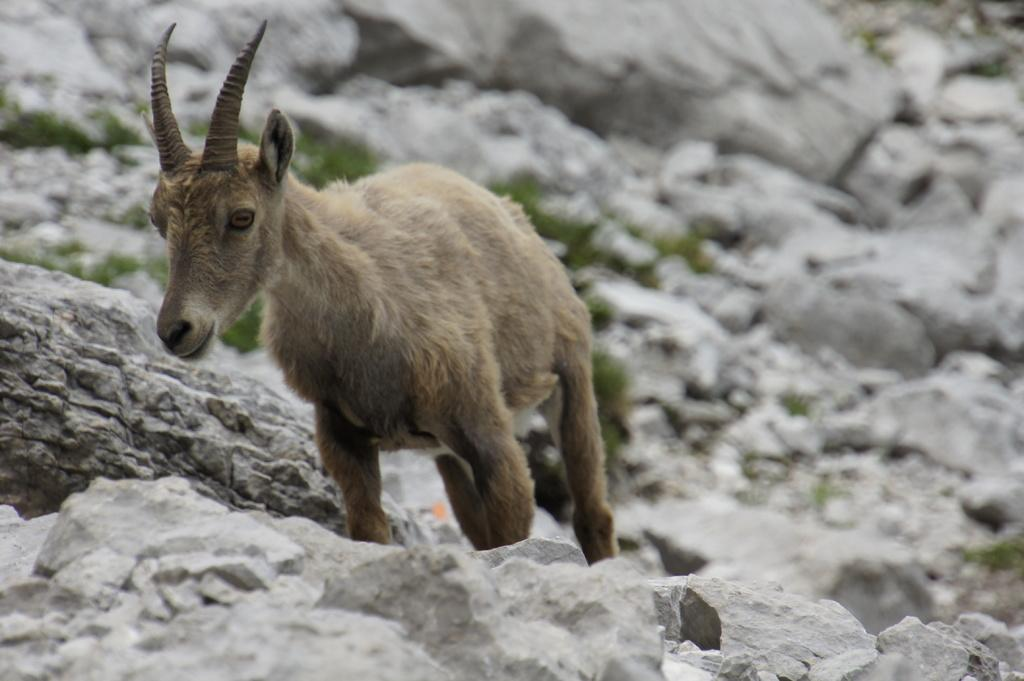What is the main subject in the center of the image? There is an animal in the center of the image. What can be seen in the background of the image? There are rocks in the background of the image. What type of vegetation is visible in the image? There is grass visible in the image. What type of wrench is being used by the animal in the image? There is no wrench present in the image; it features an animal and natural elements like rocks and grass. 